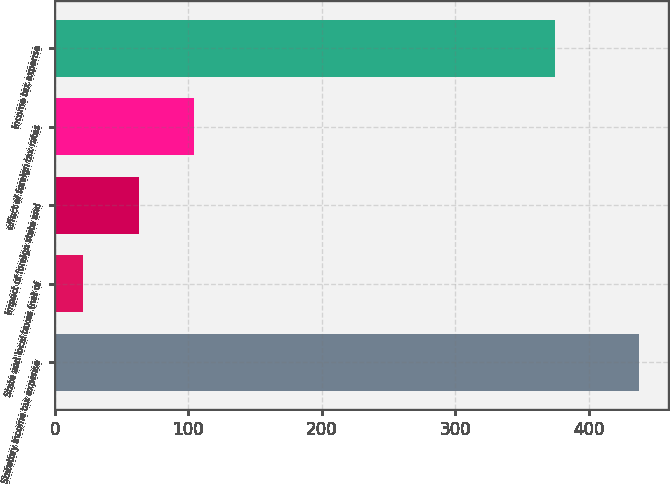Convert chart. <chart><loc_0><loc_0><loc_500><loc_500><bar_chart><fcel>Statutory income tax expense<fcel>State and local taxes (net of<fcel>impact of foreign state and<fcel>effect of foreign tax rates<fcel>income tax expense<nl><fcel>438<fcel>21<fcel>62.7<fcel>104.4<fcel>375<nl></chart> 